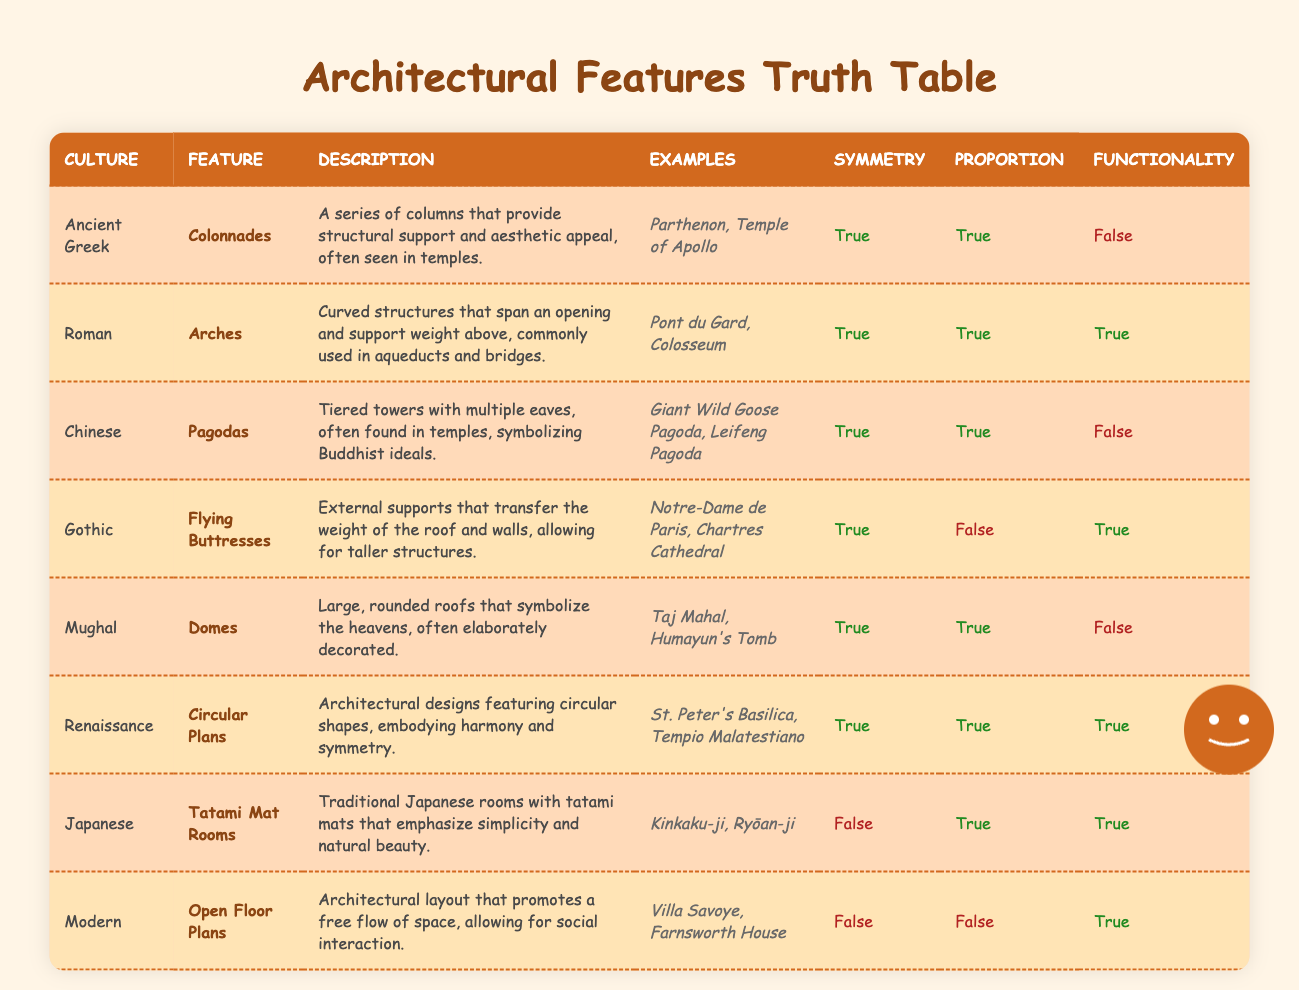What architectural feature is associated with the Ancient Greek culture? According to the table, the feature associated with the Ancient Greek culture is "Colonnades."
Answer: Colonnades Which cultures have architectural features that emphasize functionality? To determine this, we look at the "Functionality" column and see that the Roman, Gothic, Renaissance, Japanese, and Modern cultures have "True" marked for functionality.
Answer: Roman, Gothic, Renaissance, Japanese, Modern Do the Chinese Pagodas have a characteristic that emphasizes functionality? Based on the table, the characteristic value for functionality in Chinese Pagodas is marked as "False."
Answer: No What is the average proportion score of cultures that feature domes? The Mughal culture's feature "Domes" has a proportion characteristic value of "True." With only one score available, the average is 1 (since True can be counted as 1).
Answer: 1 Which architectural feature can be found in both the Roman and Gothic cultures? By examining the table, we find the Roman culture with "Arches" and the Gothic culture with "Flying Buttresses." There is no common architectural feature between those two cultures.
Answer: None Are there any cultures with features thatlack symmetry but have proportion as "True"? From the table, the Japanese culture (Tatami Mat Rooms) is the only culture with "False" for symmetry and "True" for proportion.
Answer: Yes How many cultures have both symmetry and functionality labeled as "True"? Looking at the "Symmetry" and "Functionality" columns, the cultures with both labeled as "True" are Roman, Renaissance, and Gothic. So we have three cultures.
Answer: 3 Which feature represents a historical ideal in Chinese culture? The feature listed for Chinese culture is "Pagodas," which symbolize Buddhist ideals according to the table description.
Answer: Pagodas How many cultures have features described as not functional? By checking the "Functionality" column, we see Ancient Greek, Chinese, and Mughal cultures have "False" marked for functionality. There are three such cultures.
Answer: 3 